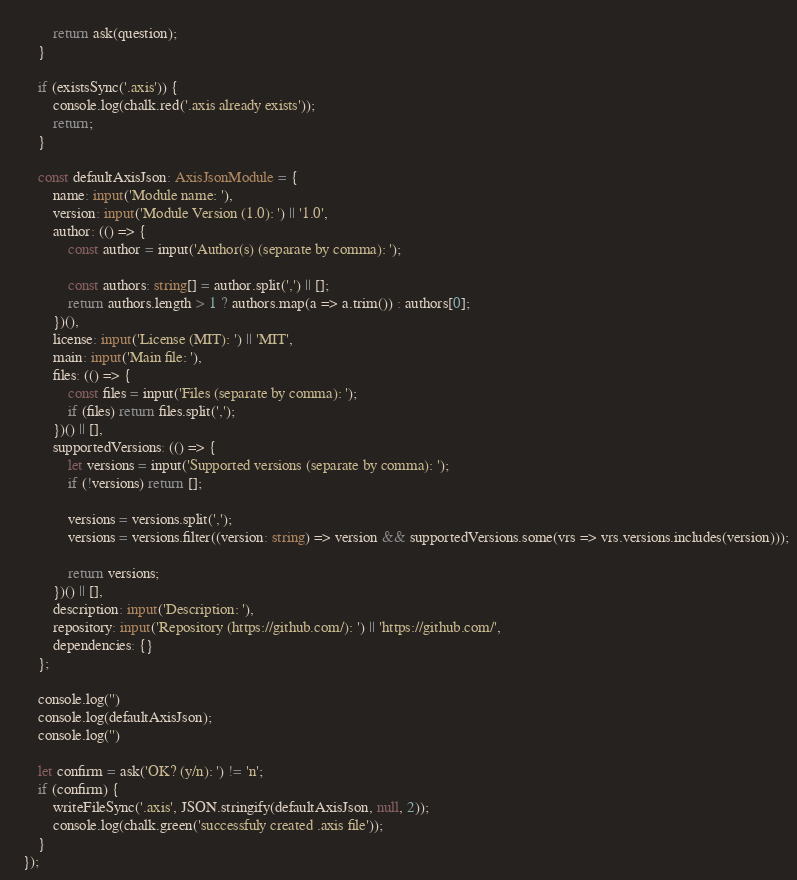<code> <loc_0><loc_0><loc_500><loc_500><_TypeScript_>                
            return ask(question);
        }

        if (existsSync('.axis')) {
            console.log(chalk.red('.axis already exists'));
            return;
        }

        const defaultAxisJson: AxisJsonModule = {
            name: input('Module name: '),
            version: input('Module Version (1.0): ') || '1.0',
            author: (() => {
                const author = input('Author(s) (separate by comma): ');

                const authors: string[] = author.split(',') || [];
                return authors.length > 1 ? authors.map(a => a.trim()) : authors[0];
            })(),
            license: input('License (MIT): ') || 'MIT',
            main: input('Main file: '),
            files: (() => {
                const files = input('Files (separate by comma): ');
                if (files) return files.split(',');
            })() || [],
            supportedVersions: (() => {
                let versions = input('Supported versions (separate by comma): ');
                if (!versions) return [];
                
                versions = versions.split(',');
                versions = versions.filter((version: string) => version && supportedVersions.some(vrs => vrs.versions.includes(version)));
                
                return versions;
            })() || [],
            description: input('Description: '),
            repository: input('Repository (https://github.com/): ') || 'https://github.com/',
            dependencies: {}
        };

        console.log('')
        console.log(defaultAxisJson);
        console.log('')
        
        let confirm = ask('OK? (y/n): ') != 'n';
        if (confirm) {
            writeFileSync('.axis', JSON.stringify(defaultAxisJson, null, 2));
            console.log(chalk.green('successfuly created .axis file'));
        }
    });</code> 